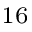<formula> <loc_0><loc_0><loc_500><loc_500>^ { 1 6 }</formula> 